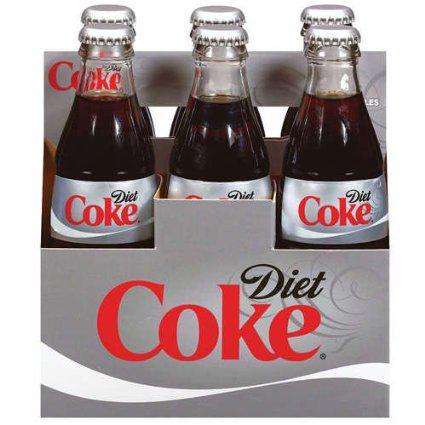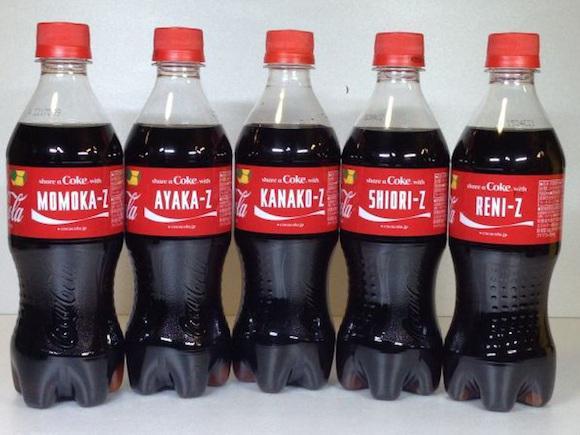The first image is the image on the left, the second image is the image on the right. Considering the images on both sides, is "The left and right image contains the same number of  bottles." valid? Answer yes or no. No. The first image is the image on the left, the second image is the image on the right. For the images shown, is this caption "There are fewer than twelve bottles in total." true? Answer yes or no. Yes. 